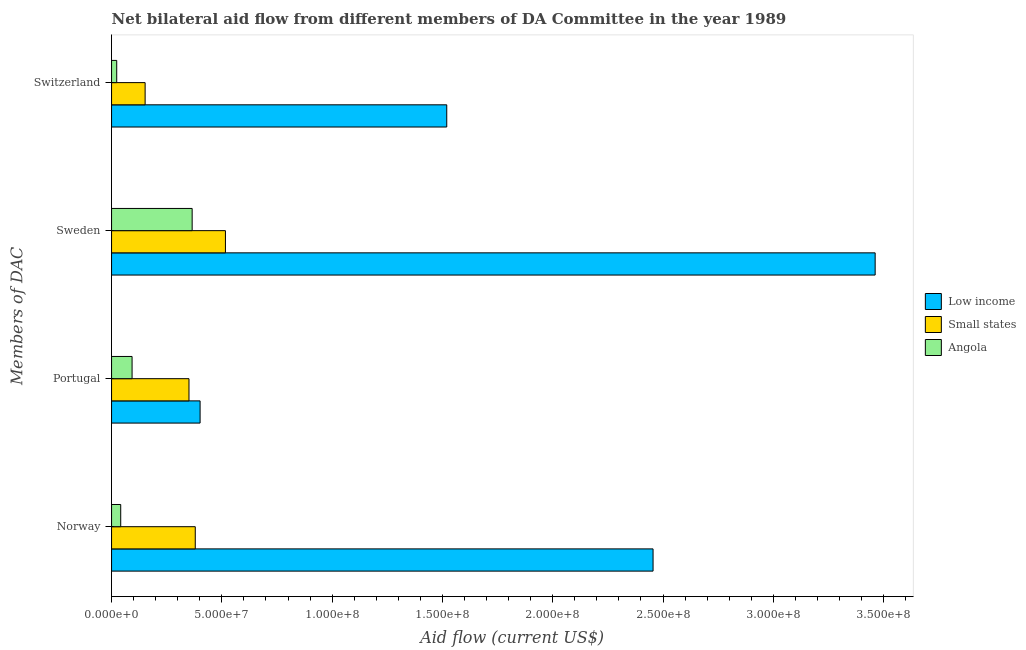How many different coloured bars are there?
Your answer should be compact. 3. Are the number of bars on each tick of the Y-axis equal?
Your answer should be very brief. Yes. How many bars are there on the 3rd tick from the top?
Offer a very short reply. 3. What is the amount of aid given by sweden in Low income?
Give a very brief answer. 3.46e+08. Across all countries, what is the maximum amount of aid given by portugal?
Provide a succinct answer. 4.01e+07. Across all countries, what is the minimum amount of aid given by portugal?
Provide a short and direct response. 9.30e+06. In which country was the amount of aid given by portugal minimum?
Provide a succinct answer. Angola. What is the total amount of aid given by norway in the graph?
Keep it short and to the point. 2.88e+08. What is the difference between the amount of aid given by switzerland in Angola and that in Low income?
Your answer should be very brief. -1.50e+08. What is the difference between the amount of aid given by switzerland in Low income and the amount of aid given by portugal in Angola?
Your answer should be compact. 1.43e+08. What is the average amount of aid given by sweden per country?
Offer a very short reply. 1.45e+08. What is the difference between the amount of aid given by norway and amount of aid given by portugal in Low income?
Ensure brevity in your answer.  2.05e+08. In how many countries, is the amount of aid given by switzerland greater than 220000000 US$?
Provide a short and direct response. 0. What is the ratio of the amount of aid given by sweden in Small states to that in Low income?
Offer a very short reply. 0.15. Is the amount of aid given by norway in Angola less than that in Small states?
Offer a terse response. Yes. What is the difference between the highest and the second highest amount of aid given by norway?
Your answer should be compact. 2.08e+08. What is the difference between the highest and the lowest amount of aid given by switzerland?
Give a very brief answer. 1.50e+08. In how many countries, is the amount of aid given by portugal greater than the average amount of aid given by portugal taken over all countries?
Offer a very short reply. 2. Is it the case that in every country, the sum of the amount of aid given by switzerland and amount of aid given by norway is greater than the sum of amount of aid given by portugal and amount of aid given by sweden?
Make the answer very short. No. What does the 1st bar from the bottom in Norway represents?
Your answer should be compact. Low income. Is it the case that in every country, the sum of the amount of aid given by norway and amount of aid given by portugal is greater than the amount of aid given by sweden?
Make the answer very short. No. How many bars are there?
Ensure brevity in your answer.  12. Are the values on the major ticks of X-axis written in scientific E-notation?
Your answer should be compact. Yes. Does the graph contain any zero values?
Your answer should be compact. No. Does the graph contain grids?
Provide a short and direct response. No. Where does the legend appear in the graph?
Your answer should be compact. Center right. How are the legend labels stacked?
Keep it short and to the point. Vertical. What is the title of the graph?
Give a very brief answer. Net bilateral aid flow from different members of DA Committee in the year 1989. Does "Myanmar" appear as one of the legend labels in the graph?
Give a very brief answer. No. What is the label or title of the X-axis?
Your response must be concise. Aid flow (current US$). What is the label or title of the Y-axis?
Keep it short and to the point. Members of DAC. What is the Aid flow (current US$) in Low income in Norway?
Offer a terse response. 2.45e+08. What is the Aid flow (current US$) of Small states in Norway?
Give a very brief answer. 3.80e+07. What is the Aid flow (current US$) of Angola in Norway?
Provide a succinct answer. 4.15e+06. What is the Aid flow (current US$) in Low income in Portugal?
Offer a very short reply. 4.01e+07. What is the Aid flow (current US$) of Small states in Portugal?
Give a very brief answer. 3.51e+07. What is the Aid flow (current US$) of Angola in Portugal?
Your answer should be compact. 9.30e+06. What is the Aid flow (current US$) of Low income in Sweden?
Your answer should be very brief. 3.46e+08. What is the Aid flow (current US$) of Small states in Sweden?
Provide a short and direct response. 5.16e+07. What is the Aid flow (current US$) in Angola in Sweden?
Make the answer very short. 3.65e+07. What is the Aid flow (current US$) of Low income in Switzerland?
Ensure brevity in your answer.  1.52e+08. What is the Aid flow (current US$) of Small states in Switzerland?
Offer a terse response. 1.52e+07. What is the Aid flow (current US$) in Angola in Switzerland?
Your response must be concise. 2.34e+06. Across all Members of DAC, what is the maximum Aid flow (current US$) in Low income?
Your answer should be very brief. 3.46e+08. Across all Members of DAC, what is the maximum Aid flow (current US$) in Small states?
Your response must be concise. 5.16e+07. Across all Members of DAC, what is the maximum Aid flow (current US$) in Angola?
Your response must be concise. 3.65e+07. Across all Members of DAC, what is the minimum Aid flow (current US$) in Low income?
Your answer should be very brief. 4.01e+07. Across all Members of DAC, what is the minimum Aid flow (current US$) of Small states?
Make the answer very short. 1.52e+07. Across all Members of DAC, what is the minimum Aid flow (current US$) in Angola?
Give a very brief answer. 2.34e+06. What is the total Aid flow (current US$) in Low income in the graph?
Give a very brief answer. 7.84e+08. What is the total Aid flow (current US$) in Small states in the graph?
Keep it short and to the point. 1.40e+08. What is the total Aid flow (current US$) in Angola in the graph?
Make the answer very short. 5.23e+07. What is the difference between the Aid flow (current US$) in Low income in Norway and that in Portugal?
Provide a short and direct response. 2.05e+08. What is the difference between the Aid flow (current US$) in Small states in Norway and that in Portugal?
Make the answer very short. 2.85e+06. What is the difference between the Aid flow (current US$) of Angola in Norway and that in Portugal?
Make the answer very short. -5.15e+06. What is the difference between the Aid flow (current US$) in Low income in Norway and that in Sweden?
Offer a very short reply. -1.01e+08. What is the difference between the Aid flow (current US$) of Small states in Norway and that in Sweden?
Keep it short and to the point. -1.37e+07. What is the difference between the Aid flow (current US$) in Angola in Norway and that in Sweden?
Give a very brief answer. -3.24e+07. What is the difference between the Aid flow (current US$) in Low income in Norway and that in Switzerland?
Your response must be concise. 9.35e+07. What is the difference between the Aid flow (current US$) in Small states in Norway and that in Switzerland?
Your answer should be very brief. 2.27e+07. What is the difference between the Aid flow (current US$) of Angola in Norway and that in Switzerland?
Give a very brief answer. 1.81e+06. What is the difference between the Aid flow (current US$) of Low income in Portugal and that in Sweden?
Keep it short and to the point. -3.06e+08. What is the difference between the Aid flow (current US$) of Small states in Portugal and that in Sweden?
Give a very brief answer. -1.65e+07. What is the difference between the Aid flow (current US$) in Angola in Portugal and that in Sweden?
Your answer should be very brief. -2.72e+07. What is the difference between the Aid flow (current US$) in Low income in Portugal and that in Switzerland?
Provide a succinct answer. -1.12e+08. What is the difference between the Aid flow (current US$) of Small states in Portugal and that in Switzerland?
Your answer should be compact. 1.99e+07. What is the difference between the Aid flow (current US$) of Angola in Portugal and that in Switzerland?
Ensure brevity in your answer.  6.96e+06. What is the difference between the Aid flow (current US$) in Low income in Sweden and that in Switzerland?
Make the answer very short. 1.94e+08. What is the difference between the Aid flow (current US$) of Small states in Sweden and that in Switzerland?
Offer a terse response. 3.64e+07. What is the difference between the Aid flow (current US$) of Angola in Sweden and that in Switzerland?
Offer a very short reply. 3.42e+07. What is the difference between the Aid flow (current US$) in Low income in Norway and the Aid flow (current US$) in Small states in Portugal?
Keep it short and to the point. 2.10e+08. What is the difference between the Aid flow (current US$) of Low income in Norway and the Aid flow (current US$) of Angola in Portugal?
Your answer should be compact. 2.36e+08. What is the difference between the Aid flow (current US$) in Small states in Norway and the Aid flow (current US$) in Angola in Portugal?
Keep it short and to the point. 2.86e+07. What is the difference between the Aid flow (current US$) of Low income in Norway and the Aid flow (current US$) of Small states in Sweden?
Your response must be concise. 1.94e+08. What is the difference between the Aid flow (current US$) in Low income in Norway and the Aid flow (current US$) in Angola in Sweden?
Your answer should be compact. 2.09e+08. What is the difference between the Aid flow (current US$) in Small states in Norway and the Aid flow (current US$) in Angola in Sweden?
Keep it short and to the point. 1.41e+06. What is the difference between the Aid flow (current US$) of Low income in Norway and the Aid flow (current US$) of Small states in Switzerland?
Offer a very short reply. 2.30e+08. What is the difference between the Aid flow (current US$) in Low income in Norway and the Aid flow (current US$) in Angola in Switzerland?
Your response must be concise. 2.43e+08. What is the difference between the Aid flow (current US$) in Small states in Norway and the Aid flow (current US$) in Angola in Switzerland?
Offer a very short reply. 3.56e+07. What is the difference between the Aid flow (current US$) of Low income in Portugal and the Aid flow (current US$) of Small states in Sweden?
Ensure brevity in your answer.  -1.15e+07. What is the difference between the Aid flow (current US$) of Low income in Portugal and the Aid flow (current US$) of Angola in Sweden?
Offer a terse response. 3.60e+06. What is the difference between the Aid flow (current US$) in Small states in Portugal and the Aid flow (current US$) in Angola in Sweden?
Offer a very short reply. -1.44e+06. What is the difference between the Aid flow (current US$) in Low income in Portugal and the Aid flow (current US$) in Small states in Switzerland?
Your answer should be compact. 2.49e+07. What is the difference between the Aid flow (current US$) of Low income in Portugal and the Aid flow (current US$) of Angola in Switzerland?
Your answer should be very brief. 3.78e+07. What is the difference between the Aid flow (current US$) of Small states in Portugal and the Aid flow (current US$) of Angola in Switzerland?
Your answer should be very brief. 3.28e+07. What is the difference between the Aid flow (current US$) in Low income in Sweden and the Aid flow (current US$) in Small states in Switzerland?
Give a very brief answer. 3.31e+08. What is the difference between the Aid flow (current US$) of Low income in Sweden and the Aid flow (current US$) of Angola in Switzerland?
Make the answer very short. 3.44e+08. What is the difference between the Aid flow (current US$) of Small states in Sweden and the Aid flow (current US$) of Angola in Switzerland?
Offer a terse response. 4.93e+07. What is the average Aid flow (current US$) in Low income per Members of DAC?
Make the answer very short. 1.96e+08. What is the average Aid flow (current US$) in Small states per Members of DAC?
Offer a very short reply. 3.50e+07. What is the average Aid flow (current US$) in Angola per Members of DAC?
Offer a very short reply. 1.31e+07. What is the difference between the Aid flow (current US$) of Low income and Aid flow (current US$) of Small states in Norway?
Offer a terse response. 2.08e+08. What is the difference between the Aid flow (current US$) of Low income and Aid flow (current US$) of Angola in Norway?
Provide a short and direct response. 2.41e+08. What is the difference between the Aid flow (current US$) in Small states and Aid flow (current US$) in Angola in Norway?
Provide a succinct answer. 3.38e+07. What is the difference between the Aid flow (current US$) in Low income and Aid flow (current US$) in Small states in Portugal?
Your answer should be very brief. 5.04e+06. What is the difference between the Aid flow (current US$) of Low income and Aid flow (current US$) of Angola in Portugal?
Keep it short and to the point. 3.08e+07. What is the difference between the Aid flow (current US$) in Small states and Aid flow (current US$) in Angola in Portugal?
Keep it short and to the point. 2.58e+07. What is the difference between the Aid flow (current US$) in Low income and Aid flow (current US$) in Small states in Sweden?
Give a very brief answer. 2.95e+08. What is the difference between the Aid flow (current US$) in Low income and Aid flow (current US$) in Angola in Sweden?
Your response must be concise. 3.10e+08. What is the difference between the Aid flow (current US$) in Small states and Aid flow (current US$) in Angola in Sweden?
Offer a terse response. 1.51e+07. What is the difference between the Aid flow (current US$) of Low income and Aid flow (current US$) of Small states in Switzerland?
Give a very brief answer. 1.37e+08. What is the difference between the Aid flow (current US$) of Low income and Aid flow (current US$) of Angola in Switzerland?
Your response must be concise. 1.50e+08. What is the difference between the Aid flow (current US$) of Small states and Aid flow (current US$) of Angola in Switzerland?
Make the answer very short. 1.29e+07. What is the ratio of the Aid flow (current US$) in Low income in Norway to that in Portugal?
Provide a succinct answer. 6.12. What is the ratio of the Aid flow (current US$) of Small states in Norway to that in Portugal?
Provide a succinct answer. 1.08. What is the ratio of the Aid flow (current US$) of Angola in Norway to that in Portugal?
Provide a short and direct response. 0.45. What is the ratio of the Aid flow (current US$) of Low income in Norway to that in Sweden?
Your response must be concise. 0.71. What is the ratio of the Aid flow (current US$) in Small states in Norway to that in Sweden?
Make the answer very short. 0.73. What is the ratio of the Aid flow (current US$) in Angola in Norway to that in Sweden?
Your response must be concise. 0.11. What is the ratio of the Aid flow (current US$) in Low income in Norway to that in Switzerland?
Make the answer very short. 1.62. What is the ratio of the Aid flow (current US$) in Small states in Norway to that in Switzerland?
Make the answer very short. 2.49. What is the ratio of the Aid flow (current US$) in Angola in Norway to that in Switzerland?
Your response must be concise. 1.77. What is the ratio of the Aid flow (current US$) in Low income in Portugal to that in Sweden?
Keep it short and to the point. 0.12. What is the ratio of the Aid flow (current US$) of Small states in Portugal to that in Sweden?
Make the answer very short. 0.68. What is the ratio of the Aid flow (current US$) in Angola in Portugal to that in Sweden?
Your answer should be very brief. 0.25. What is the ratio of the Aid flow (current US$) in Low income in Portugal to that in Switzerland?
Give a very brief answer. 0.26. What is the ratio of the Aid flow (current US$) in Small states in Portugal to that in Switzerland?
Give a very brief answer. 2.31. What is the ratio of the Aid flow (current US$) of Angola in Portugal to that in Switzerland?
Keep it short and to the point. 3.97. What is the ratio of the Aid flow (current US$) of Low income in Sweden to that in Switzerland?
Offer a very short reply. 2.28. What is the ratio of the Aid flow (current US$) in Small states in Sweden to that in Switzerland?
Your answer should be very brief. 3.39. What is the ratio of the Aid flow (current US$) of Angola in Sweden to that in Switzerland?
Make the answer very short. 15.62. What is the difference between the highest and the second highest Aid flow (current US$) in Low income?
Provide a succinct answer. 1.01e+08. What is the difference between the highest and the second highest Aid flow (current US$) in Small states?
Your response must be concise. 1.37e+07. What is the difference between the highest and the second highest Aid flow (current US$) of Angola?
Provide a succinct answer. 2.72e+07. What is the difference between the highest and the lowest Aid flow (current US$) in Low income?
Offer a terse response. 3.06e+08. What is the difference between the highest and the lowest Aid flow (current US$) of Small states?
Your response must be concise. 3.64e+07. What is the difference between the highest and the lowest Aid flow (current US$) in Angola?
Make the answer very short. 3.42e+07. 